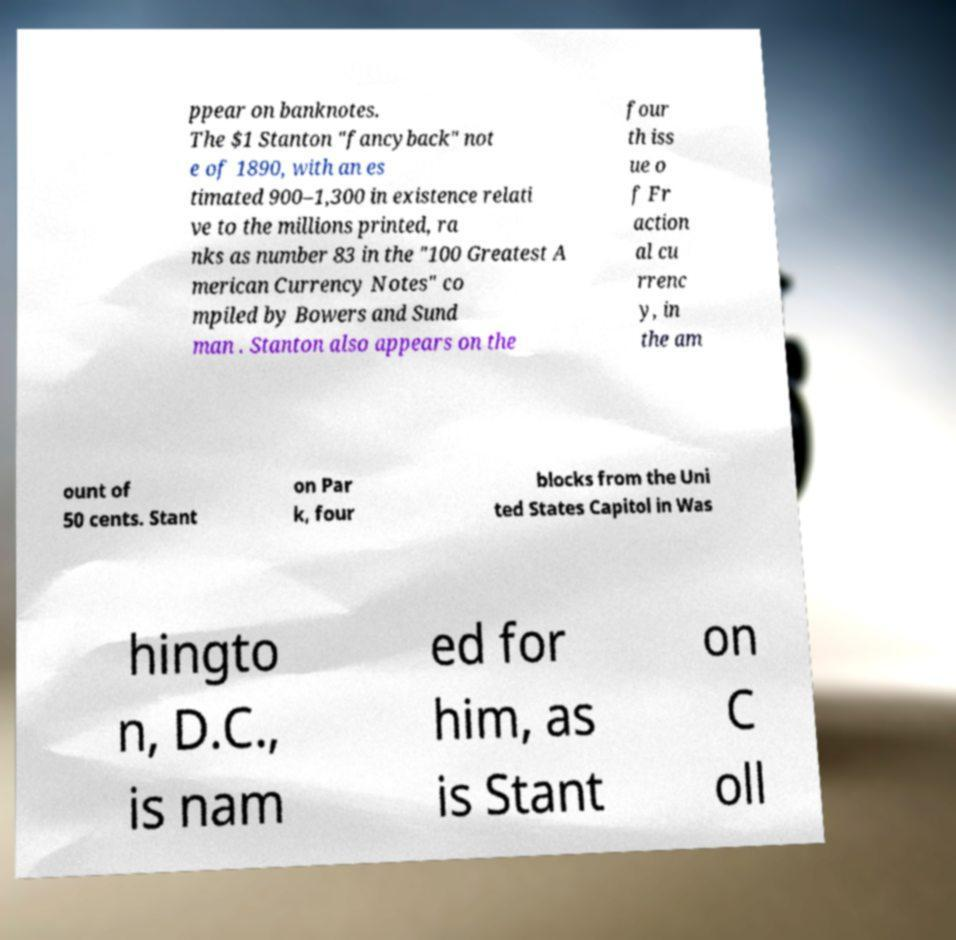I need the written content from this picture converted into text. Can you do that? ppear on banknotes. The $1 Stanton "fancyback" not e of 1890, with an es timated 900–1,300 in existence relati ve to the millions printed, ra nks as number 83 in the "100 Greatest A merican Currency Notes" co mpiled by Bowers and Sund man . Stanton also appears on the four th iss ue o f Fr action al cu rrenc y, in the am ount of 50 cents. Stant on Par k, four blocks from the Uni ted States Capitol in Was hingto n, D.C., is nam ed for him, as is Stant on C oll 